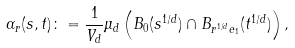Convert formula to latex. <formula><loc_0><loc_0><loc_500><loc_500>\alpha _ { r } ( s , t ) \colon = \frac { 1 } { V _ { d } } \mu _ { d } \left ( B _ { 0 } ( s ^ { 1 / d } ) \cap B _ { r ^ { 1 / d } e _ { 1 } } ( t ^ { 1 / d } ) \right ) ,</formula> 